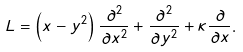<formula> <loc_0><loc_0><loc_500><loc_500>L = \left ( x - y ^ { 2 } \right ) \frac { \partial ^ { 2 } } { \partial x ^ { 2 } } + \frac { \partial ^ { 2 } } { \partial y ^ { 2 } } + \kappa \frac { \partial } { \partial x } .</formula> 